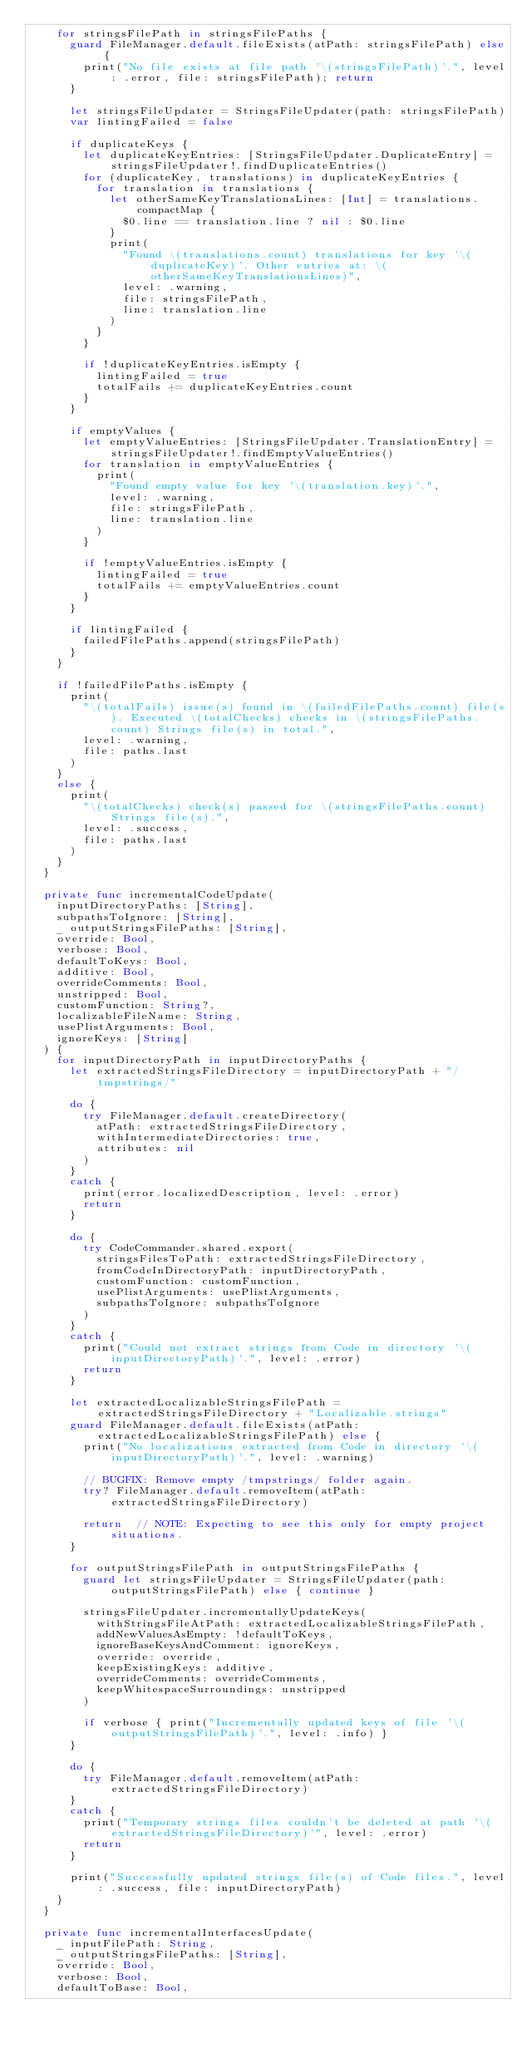Convert code to text. <code><loc_0><loc_0><loc_500><loc_500><_Swift_>    for stringsFilePath in stringsFilePaths {
      guard FileManager.default.fileExists(atPath: stringsFilePath) else {
        print("No file exists at file path '\(stringsFilePath)'.", level: .error, file: stringsFilePath); return
      }

      let stringsFileUpdater = StringsFileUpdater(path: stringsFilePath)
      var lintingFailed = false

      if duplicateKeys {
        let duplicateKeyEntries: [StringsFileUpdater.DuplicateEntry] = stringsFileUpdater!.findDuplicateEntries()
        for (duplicateKey, translations) in duplicateKeyEntries {
          for translation in translations {
            let otherSameKeyTranslationsLines: [Int] = translations.compactMap {
              $0.line == translation.line ? nil : $0.line
            }
            print(
              "Found \(translations.count) translations for key '\(duplicateKey)'. Other entries at: \(otherSameKeyTranslationsLines)",
              level: .warning,
              file: stringsFilePath,
              line: translation.line
            )
          }
        }

        if !duplicateKeyEntries.isEmpty {
          lintingFailed = true
          totalFails += duplicateKeyEntries.count
        }
      }

      if emptyValues {
        let emptyValueEntries: [StringsFileUpdater.TranslationEntry] = stringsFileUpdater!.findEmptyValueEntries()
        for translation in emptyValueEntries {
          print(
            "Found empty value for key '\(translation.key)'.",
            level: .warning,
            file: stringsFilePath,
            line: translation.line
          )
        }

        if !emptyValueEntries.isEmpty {
          lintingFailed = true
          totalFails += emptyValueEntries.count
        }
      }

      if lintingFailed {
        failedFilePaths.append(stringsFilePath)
      }
    }

    if !failedFilePaths.isEmpty {
      print(
        "\(totalFails) issue(s) found in \(failedFilePaths.count) file(s). Executed \(totalChecks) checks in \(stringsFilePaths.count) Strings file(s) in total.",
        level: .warning,
        file: paths.last
      )
    }
    else {
      print(
        "\(totalChecks) check(s) passed for \(stringsFilePaths.count) Strings file(s).",
        level: .success,
        file: paths.last
      )
    }
  }

  private func incrementalCodeUpdate(
    inputDirectoryPaths: [String],
    subpathsToIgnore: [String],
    _ outputStringsFilePaths: [String],
    override: Bool,
    verbose: Bool,
    defaultToKeys: Bool,
    additive: Bool,
    overrideComments: Bool,
    unstripped: Bool,
    customFunction: String?,
    localizableFileName: String,
    usePlistArguments: Bool,
    ignoreKeys: [String]
  ) {
    for inputDirectoryPath in inputDirectoryPaths {
      let extractedStringsFileDirectory = inputDirectoryPath + "/tmpstrings/"

      do {
        try FileManager.default.createDirectory(
          atPath: extractedStringsFileDirectory,
          withIntermediateDirectories: true,
          attributes: nil
        )
      }
      catch {
        print(error.localizedDescription, level: .error)
        return
      }

      do {
        try CodeCommander.shared.export(
          stringsFilesToPath: extractedStringsFileDirectory,
          fromCodeInDirectoryPath: inputDirectoryPath,
          customFunction: customFunction,
          usePlistArguments: usePlistArguments,
          subpathsToIgnore: subpathsToIgnore
        )
      }
      catch {
        print("Could not extract strings from Code in directory '\(inputDirectoryPath)'.", level: .error)
        return
      }

      let extractedLocalizableStringsFilePath = extractedStringsFileDirectory + "Localizable.strings"
      guard FileManager.default.fileExists(atPath: extractedLocalizableStringsFilePath) else {
        print("No localizations extracted from Code in directory '\(inputDirectoryPath)'.", level: .warning)

        // BUGFIX: Remove empty /tmpstrings/ folder again.
        try? FileManager.default.removeItem(atPath: extractedStringsFileDirectory)

        return  // NOTE: Expecting to see this only for empty project situations.
      }

      for outputStringsFilePath in outputStringsFilePaths {
        guard let stringsFileUpdater = StringsFileUpdater(path: outputStringsFilePath) else { continue }

        stringsFileUpdater.incrementallyUpdateKeys(
          withStringsFileAtPath: extractedLocalizableStringsFilePath,
          addNewValuesAsEmpty: !defaultToKeys,
          ignoreBaseKeysAndComment: ignoreKeys,
          override: override,
          keepExistingKeys: additive,
          overrideComments: overrideComments,
          keepWhitespaceSurroundings: unstripped
        )

        if verbose { print("Incrementally updated keys of file '\(outputStringsFilePath)'.", level: .info) }
      }

      do {
        try FileManager.default.removeItem(atPath: extractedStringsFileDirectory)
      }
      catch {
        print("Temporary strings files couldn't be deleted at path '\(extractedStringsFileDirectory)'", level: .error)
        return
      }

      print("Successfully updated strings file(s) of Code files.", level: .success, file: inputDirectoryPath)
    }
  }

  private func incrementalInterfacesUpdate(
    _ inputFilePath: String,
    _ outputStringsFilePaths: [String],
    override: Bool,
    verbose: Bool,
    defaultToBase: Bool,</code> 